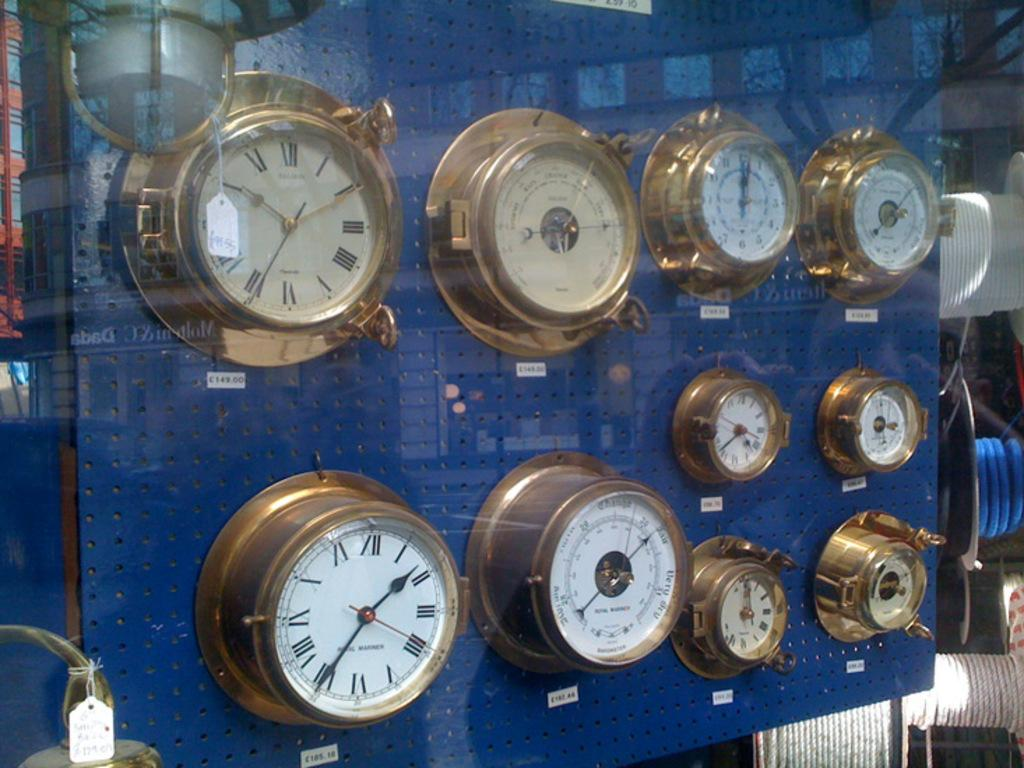<image>
Present a compact description of the photo's key features. The lower left ship's clock in this case has the numeral VI at the bottom of the face. 